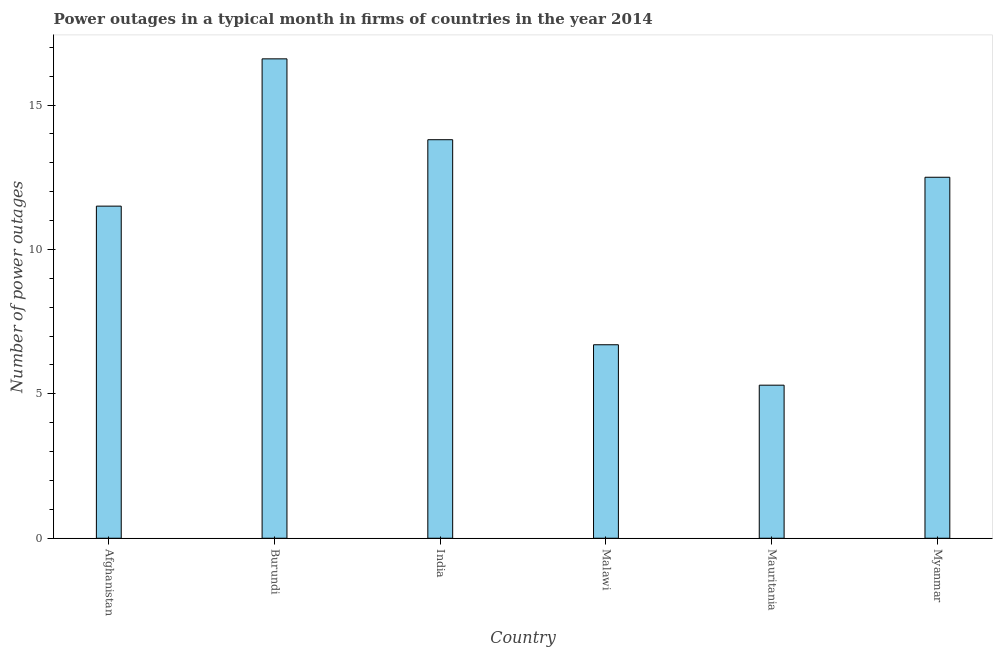Does the graph contain any zero values?
Ensure brevity in your answer.  No. What is the title of the graph?
Provide a succinct answer. Power outages in a typical month in firms of countries in the year 2014. What is the label or title of the Y-axis?
Offer a very short reply. Number of power outages. What is the number of power outages in Myanmar?
Provide a succinct answer. 12.5. Across all countries, what is the maximum number of power outages?
Offer a terse response. 16.6. Across all countries, what is the minimum number of power outages?
Your answer should be compact. 5.3. In which country was the number of power outages maximum?
Provide a short and direct response. Burundi. In which country was the number of power outages minimum?
Your answer should be compact. Mauritania. What is the sum of the number of power outages?
Your response must be concise. 66.4. What is the difference between the number of power outages in India and Myanmar?
Your response must be concise. 1.3. What is the average number of power outages per country?
Offer a very short reply. 11.07. In how many countries, is the number of power outages greater than 2 ?
Provide a short and direct response. 6. What is the ratio of the number of power outages in Afghanistan to that in Mauritania?
Your answer should be compact. 2.17. Is the difference between the number of power outages in Burundi and India greater than the difference between any two countries?
Offer a terse response. No. Are all the bars in the graph horizontal?
Your response must be concise. No. How many countries are there in the graph?
Offer a very short reply. 6. What is the difference between two consecutive major ticks on the Y-axis?
Provide a short and direct response. 5. Are the values on the major ticks of Y-axis written in scientific E-notation?
Provide a succinct answer. No. What is the Number of power outages in Afghanistan?
Give a very brief answer. 11.5. What is the Number of power outages in Malawi?
Ensure brevity in your answer.  6.7. What is the difference between the Number of power outages in Afghanistan and Burundi?
Your response must be concise. -5.1. What is the difference between the Number of power outages in Afghanistan and India?
Make the answer very short. -2.3. What is the difference between the Number of power outages in Afghanistan and Malawi?
Give a very brief answer. 4.8. What is the difference between the Number of power outages in Afghanistan and Mauritania?
Make the answer very short. 6.2. What is the difference between the Number of power outages in Afghanistan and Myanmar?
Offer a very short reply. -1. What is the difference between the Number of power outages in Burundi and Malawi?
Provide a short and direct response. 9.9. What is the difference between the Number of power outages in Burundi and Mauritania?
Your response must be concise. 11.3. What is the difference between the Number of power outages in India and Malawi?
Provide a short and direct response. 7.1. What is the difference between the Number of power outages in India and Myanmar?
Your response must be concise. 1.3. What is the difference between the Number of power outages in Malawi and Mauritania?
Ensure brevity in your answer.  1.4. What is the difference between the Number of power outages in Mauritania and Myanmar?
Your answer should be compact. -7.2. What is the ratio of the Number of power outages in Afghanistan to that in Burundi?
Your answer should be very brief. 0.69. What is the ratio of the Number of power outages in Afghanistan to that in India?
Offer a very short reply. 0.83. What is the ratio of the Number of power outages in Afghanistan to that in Malawi?
Ensure brevity in your answer.  1.72. What is the ratio of the Number of power outages in Afghanistan to that in Mauritania?
Your response must be concise. 2.17. What is the ratio of the Number of power outages in Burundi to that in India?
Your response must be concise. 1.2. What is the ratio of the Number of power outages in Burundi to that in Malawi?
Keep it short and to the point. 2.48. What is the ratio of the Number of power outages in Burundi to that in Mauritania?
Give a very brief answer. 3.13. What is the ratio of the Number of power outages in Burundi to that in Myanmar?
Keep it short and to the point. 1.33. What is the ratio of the Number of power outages in India to that in Malawi?
Your response must be concise. 2.06. What is the ratio of the Number of power outages in India to that in Mauritania?
Your response must be concise. 2.6. What is the ratio of the Number of power outages in India to that in Myanmar?
Your response must be concise. 1.1. What is the ratio of the Number of power outages in Malawi to that in Mauritania?
Provide a succinct answer. 1.26. What is the ratio of the Number of power outages in Malawi to that in Myanmar?
Give a very brief answer. 0.54. What is the ratio of the Number of power outages in Mauritania to that in Myanmar?
Your response must be concise. 0.42. 